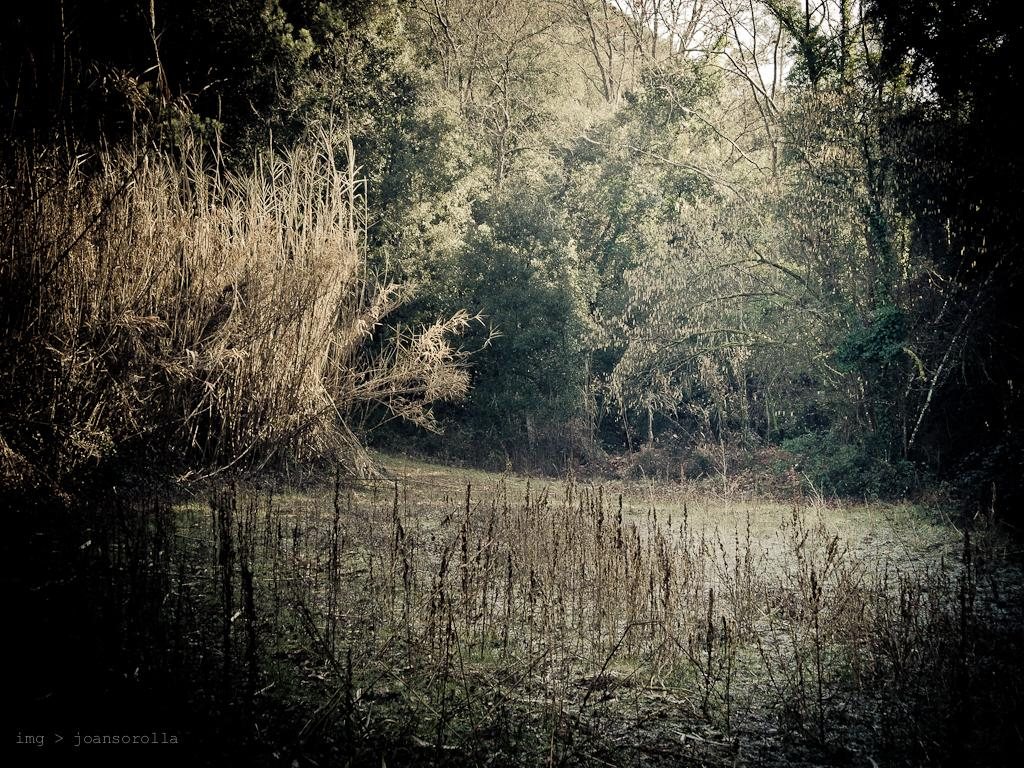What type of vegetation can be seen in the image? There are trees, grass, and plants in the image. Can you describe the ground in the image? The ground in the image is covered with grass. What other types of plants are present in the image besides trees? There are plants other than trees in the image, but specific details about them are not provided. How many summers does it take for the plants to grow to their full size in the image? The provided facts do not mention any information about the plants' growth or the concept of summer, so it is impossible to answer this question based on the given information. 